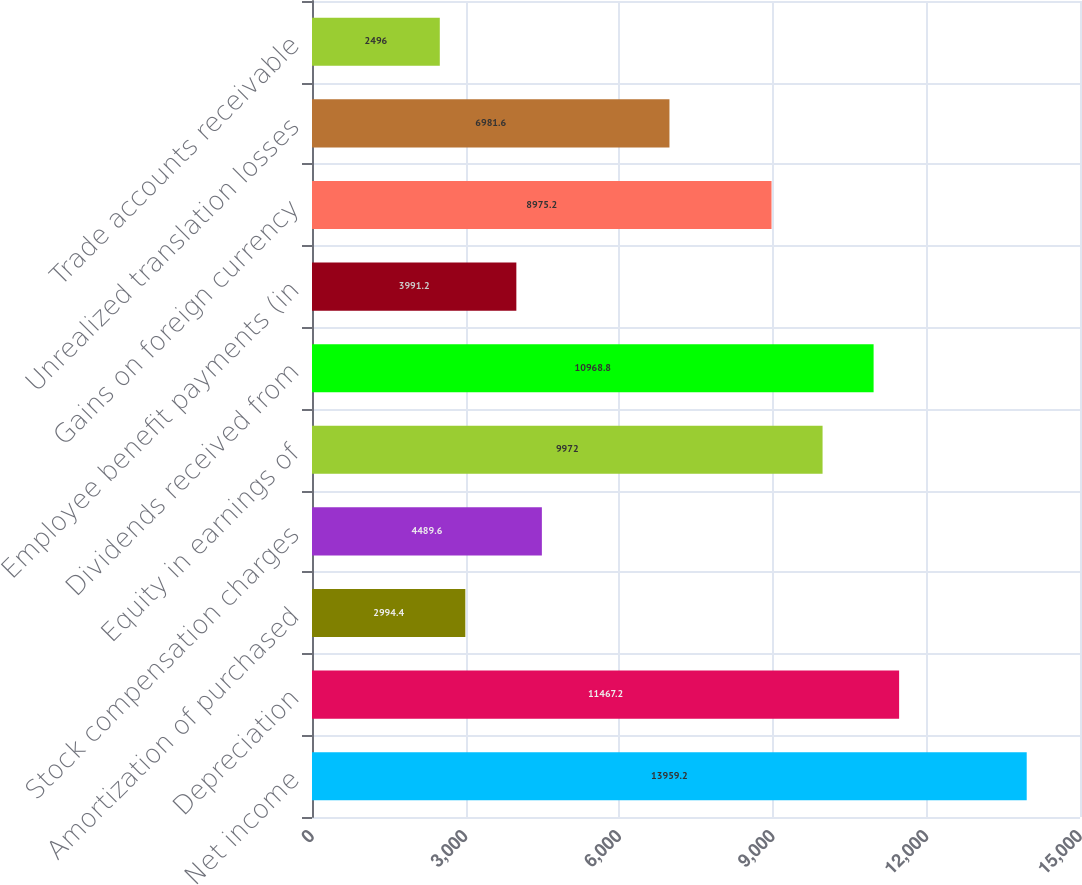<chart> <loc_0><loc_0><loc_500><loc_500><bar_chart><fcel>Net income<fcel>Depreciation<fcel>Amortization of purchased<fcel>Stock compensation charges<fcel>Equity in earnings of<fcel>Dividends received from<fcel>Employee benefit payments (in<fcel>Gains on foreign currency<fcel>Unrealized translation losses<fcel>Trade accounts receivable<nl><fcel>13959.2<fcel>11467.2<fcel>2994.4<fcel>4489.6<fcel>9972<fcel>10968.8<fcel>3991.2<fcel>8975.2<fcel>6981.6<fcel>2496<nl></chart> 